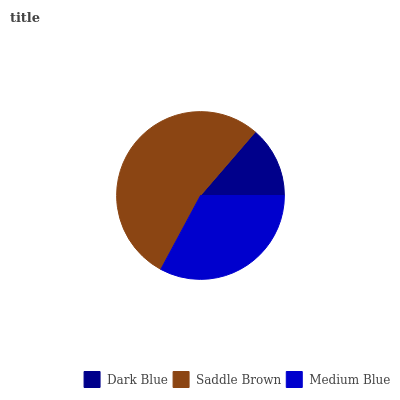Is Dark Blue the minimum?
Answer yes or no. Yes. Is Saddle Brown the maximum?
Answer yes or no. Yes. Is Medium Blue the minimum?
Answer yes or no. No. Is Medium Blue the maximum?
Answer yes or no. No. Is Saddle Brown greater than Medium Blue?
Answer yes or no. Yes. Is Medium Blue less than Saddle Brown?
Answer yes or no. Yes. Is Medium Blue greater than Saddle Brown?
Answer yes or no. No. Is Saddle Brown less than Medium Blue?
Answer yes or no. No. Is Medium Blue the high median?
Answer yes or no. Yes. Is Medium Blue the low median?
Answer yes or no. Yes. Is Saddle Brown the high median?
Answer yes or no. No. Is Saddle Brown the low median?
Answer yes or no. No. 